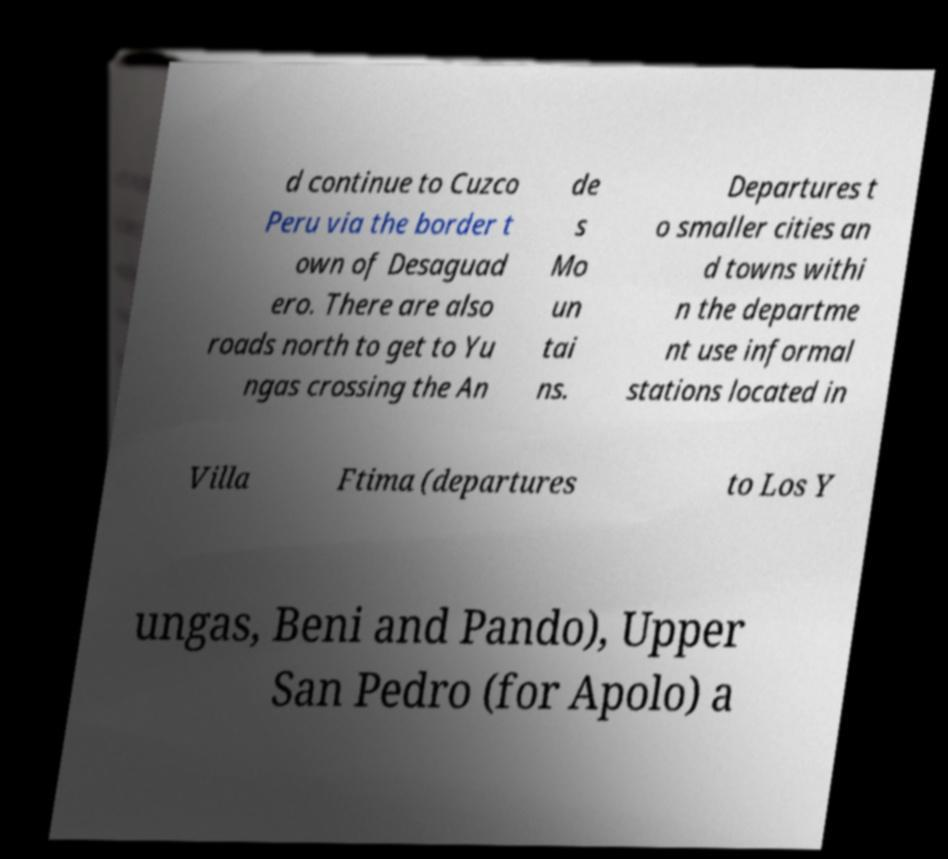Could you assist in decoding the text presented in this image and type it out clearly? d continue to Cuzco Peru via the border t own of Desaguad ero. There are also roads north to get to Yu ngas crossing the An de s Mo un tai ns. Departures t o smaller cities an d towns withi n the departme nt use informal stations located in Villa Ftima (departures to Los Y ungas, Beni and Pando), Upper San Pedro (for Apolo) a 